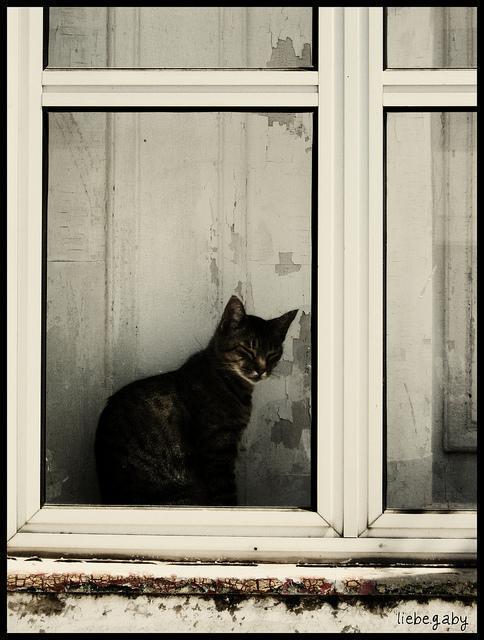How many people are wearing glasses?
Give a very brief answer. 0. 